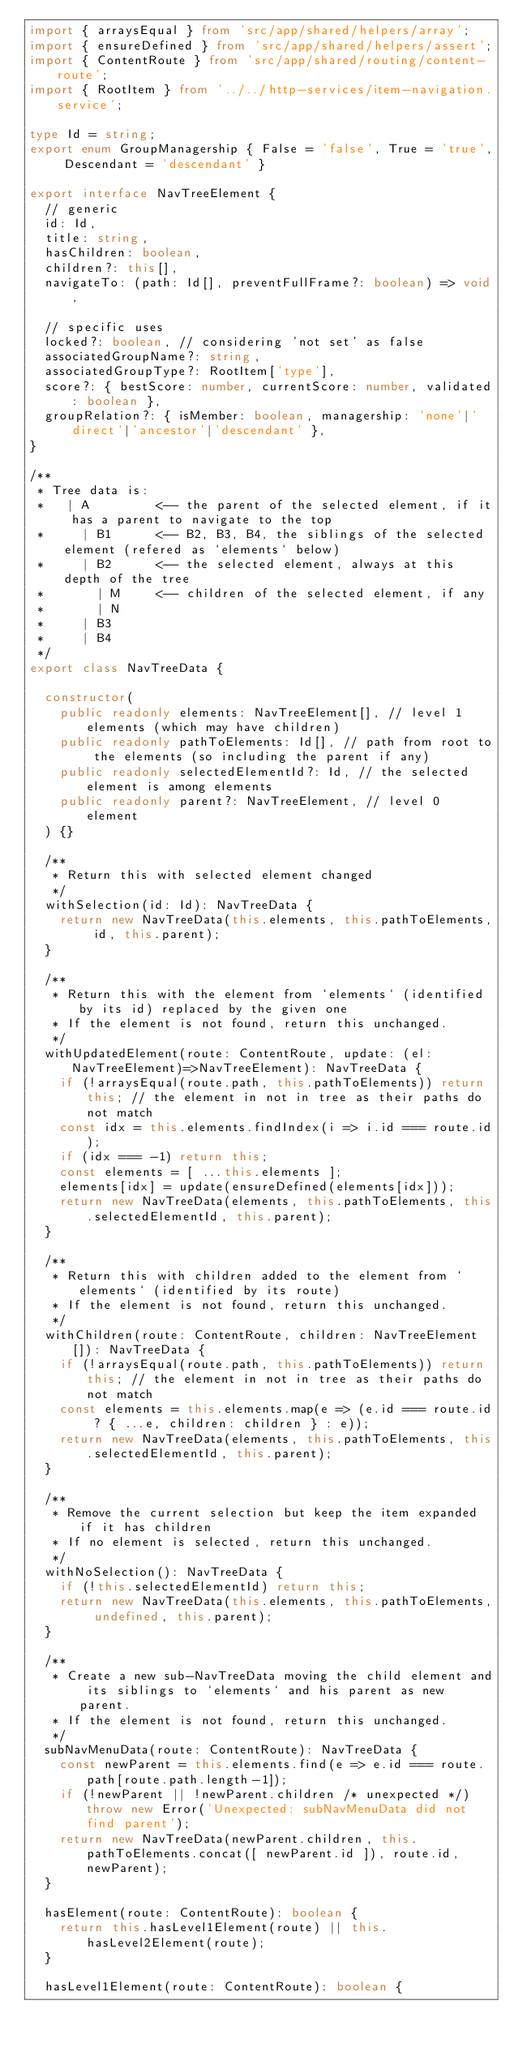<code> <loc_0><loc_0><loc_500><loc_500><_TypeScript_>import { arraysEqual } from 'src/app/shared/helpers/array';
import { ensureDefined } from 'src/app/shared/helpers/assert';
import { ContentRoute } from 'src/app/shared/routing/content-route';
import { RootItem } from '../../http-services/item-navigation.service';

type Id = string;
export enum GroupManagership { False = 'false', True = 'true', Descendant = 'descendant' }

export interface NavTreeElement {
  // generic
  id: Id,
  title: string,
  hasChildren: boolean,
  children?: this[],
  navigateTo: (path: Id[], preventFullFrame?: boolean) => void,

  // specific uses
  locked?: boolean, // considering 'not set' as false
  associatedGroupName?: string,
  associatedGroupType?: RootItem['type'],
  score?: { bestScore: number, currentScore: number, validated: boolean },
  groupRelation?: { isMember: boolean, managership: 'none'|'direct'|'ancestor'|'descendant' },
}

/**
 * Tree data is:
 *   | A         <-- the parent of the selected element, if it has a parent to navigate to the top
 *     | B1      <-- B2, B3, B4, the siblings of the selected element (refered as `elements` below)
 *     | B2      <-- the selected element, always at this depth of the tree
 *       | M     <-- children of the selected element, if any
 *       | N
 *     | B3
 *     | B4
 */
export class NavTreeData {

  constructor(
    public readonly elements: NavTreeElement[], // level 1 elements (which may have children)
    public readonly pathToElements: Id[], // path from root to the elements (so including the parent if any)
    public readonly selectedElementId?: Id, // the selected element is among elements
    public readonly parent?: NavTreeElement, // level 0 element
  ) {}

  /**
   * Return this with selected element changed
   */
  withSelection(id: Id): NavTreeData {
    return new NavTreeData(this.elements, this.pathToElements, id, this.parent);
  }

  /**
   * Return this with the element from `elements` (identified by its id) replaced by the given one
   * If the element is not found, return this unchanged.
   */
  withUpdatedElement(route: ContentRoute, update: (el:NavTreeElement)=>NavTreeElement): NavTreeData {
    if (!arraysEqual(route.path, this.pathToElements)) return this; // the element in not in tree as their paths do not match
    const idx = this.elements.findIndex(i => i.id === route.id);
    if (idx === -1) return this;
    const elements = [ ...this.elements ];
    elements[idx] = update(ensureDefined(elements[idx]));
    return new NavTreeData(elements, this.pathToElements, this.selectedElementId, this.parent);
  }

  /**
   * Return this with children added to the element from `elements` (identified by its route)
   * If the element is not found, return this unchanged.
   */
  withChildren(route: ContentRoute, children: NavTreeElement[]): NavTreeData {
    if (!arraysEqual(route.path, this.pathToElements)) return this; // the element in not in tree as their paths do not match
    const elements = this.elements.map(e => (e.id === route.id ? { ...e, children: children } : e));
    return new NavTreeData(elements, this.pathToElements, this.selectedElementId, this.parent);
  }

  /**
   * Remove the current selection but keep the item expanded if it has children
   * If no element is selected, return this unchanged.
   */
  withNoSelection(): NavTreeData {
    if (!this.selectedElementId) return this;
    return new NavTreeData(this.elements, this.pathToElements, undefined, this.parent);
  }

  /**
   * Create a new sub-NavTreeData moving the child element and its siblings to `elements` and his parent as new parent.
   * If the element is not found, return this unchanged.
   */
  subNavMenuData(route: ContentRoute): NavTreeData {
    const newParent = this.elements.find(e => e.id === route.path[route.path.length-1]);
    if (!newParent || !newParent.children /* unexpected */) throw new Error('Unexpected: subNavMenuData did not find parent');
    return new NavTreeData(newParent.children, this.pathToElements.concat([ newParent.id ]), route.id, newParent);
  }

  hasElement(route: ContentRoute): boolean {
    return this.hasLevel1Element(route) || this.hasLevel2Element(route);
  }

  hasLevel1Element(route: ContentRoute): boolean {</code> 